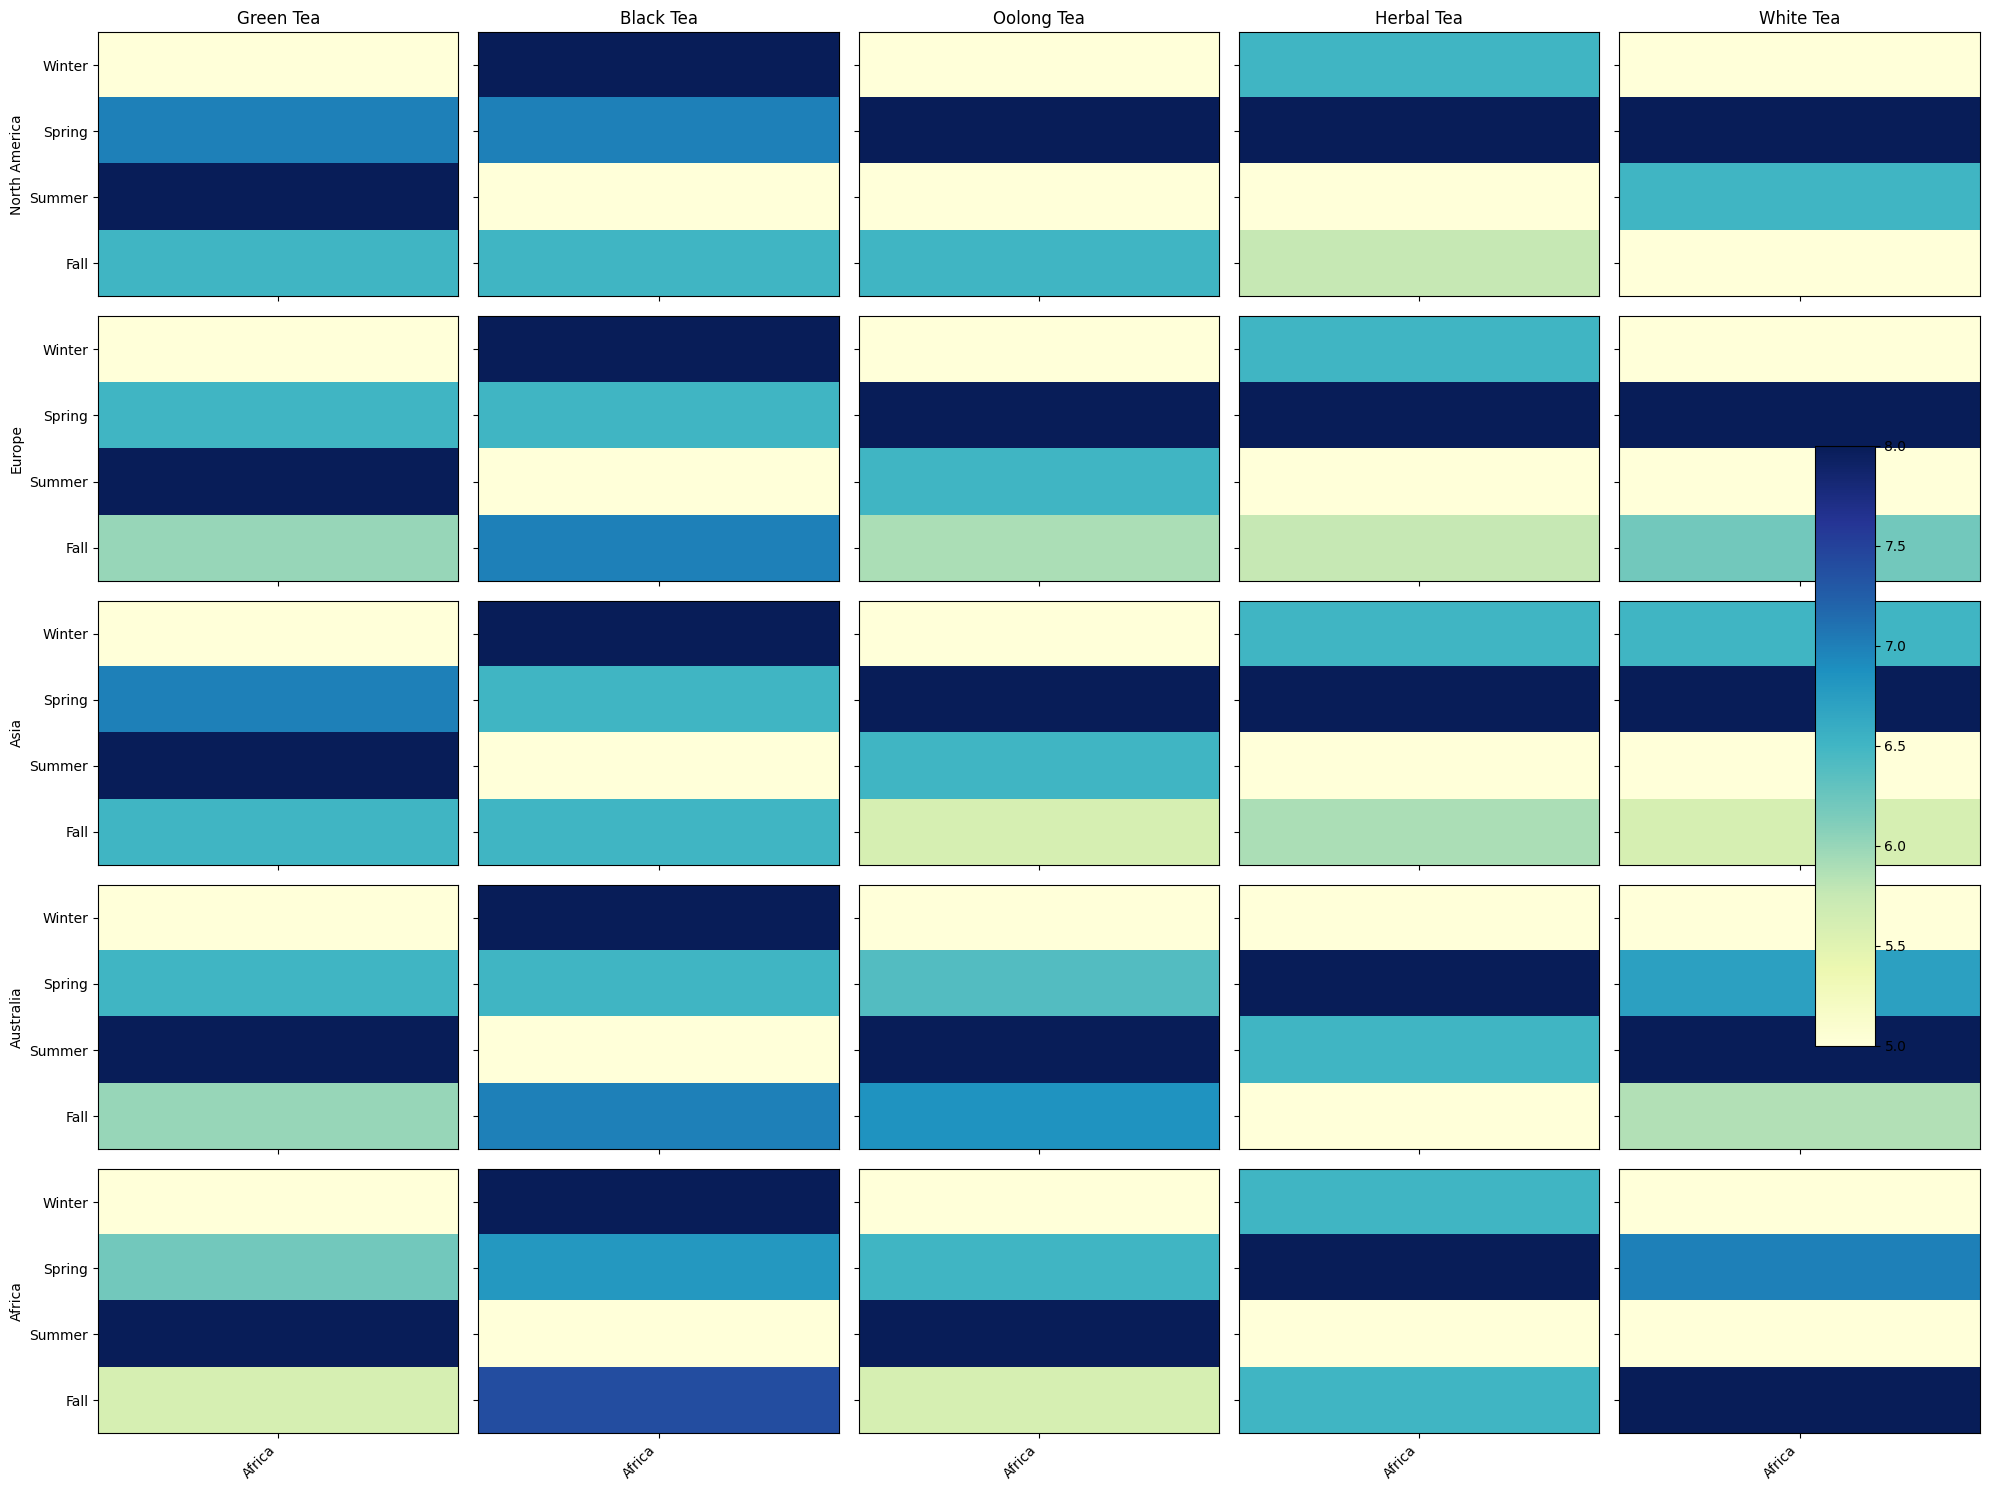Which region has the highest popularity for black tea in winter? By looking at the heatmap for black tea column and winter row, we identify the cell with the darkest shade. Africa has the highest popularity value for black tea in winter, which is 85.
Answer: Africa How does the popularity of green tea in Asia change from summer to fall? By observing the cells for green tea in the Asia row for summer and fall, the color intensity indicates the popularity values. Green tea popularity decreases from 70 in summer to 55 in fall, indicating a color change from darker to slightly lighter shade.
Answer: Decreases Compare the popularity of herbal tea in Europe and North America during spring. Which one is higher? We locate the cells for herbal tea in Europe during spring and North America during spring. Europe has a value of 45, and North America has a value of 50. Therefore, North America has a higher popularity for herbal tea in spring.
Answer: North America What is the difference in popularity for oolong tea between North America and Africa in fall? Find the cells for oolong tea in fall for North America and Africa. North America has a value of 25, and Africa has a value of 12. The difference is calculated as 25 - 12.
Answer: 13 What is the average popularity of black tea in Australia across all seasons? Identify the popularity values for black tea in Australia for winter (80), spring (65), summer (50), and fall (70). Calculate the average: (80 + 65 + 50 + 70) / 4.
Answer: 66.25 Which tea variety has the lowest popularity in Europe during winter? Look at the heatmap cells for all tea varieties in Europe during winter. The value for oolong tea is the lowest at 15.
Answer: Oolong tea Is the popularity of white tea in Africa increasing or decreasing from spring to summer? Compare the cells for white tea in Africa from spring to summer. The popularity drops from 7 to 5, so it is decreasing.
Answer: Decreasing What visual pattern do you see for herbal tea popularity in terms of color across all seasons for Asia? Observe the color pattern for herbal tea over all seasons in Asia. The colors move from a lighter shade in winter and gradually become darker, then lighter again in summer and slightly darker in fall, reflecting values from 20 (winter), 25 (spring), 15 (summer), to 18 (fall).
Answer: Fluctuating pattern What's the aggregate popularity of green tea in all regions during spring? Sum up values for green tea in all regions during spring: North America (50), Europe (40), Asia (60), Australia (35), and Africa (25). The total is 50 + 40 + 60 + 35 + 25 = 210.
Answer: 210 Which geographic region has the highest overall average popularity for black tea across all seasons? Calculate the average values for black tea across all seasons for each geographic region and compare. North America: (70+60+40+55)/4 = 56.25, Europe: (75+60+45+65)/4 = 61.25, Asia: (60+50+40+50)/4 = 50, Australia: (80+65+50+70)/4 = 66.25, Africa: (85+75+60+80)/4 = 75. Thus, Africa has the highest overall average popularity for black tea.
Answer: Africa 